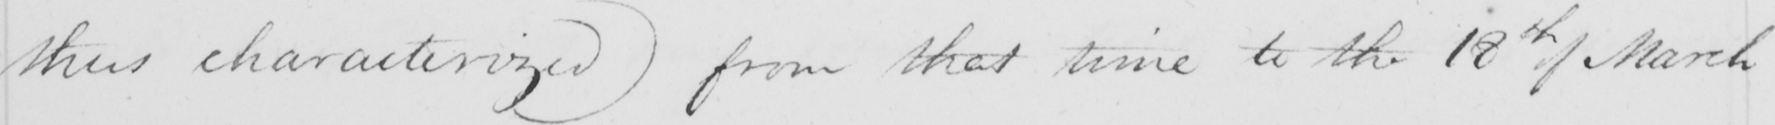What is written in this line of handwriting? thus characterized )  from that time to the 18th of March 